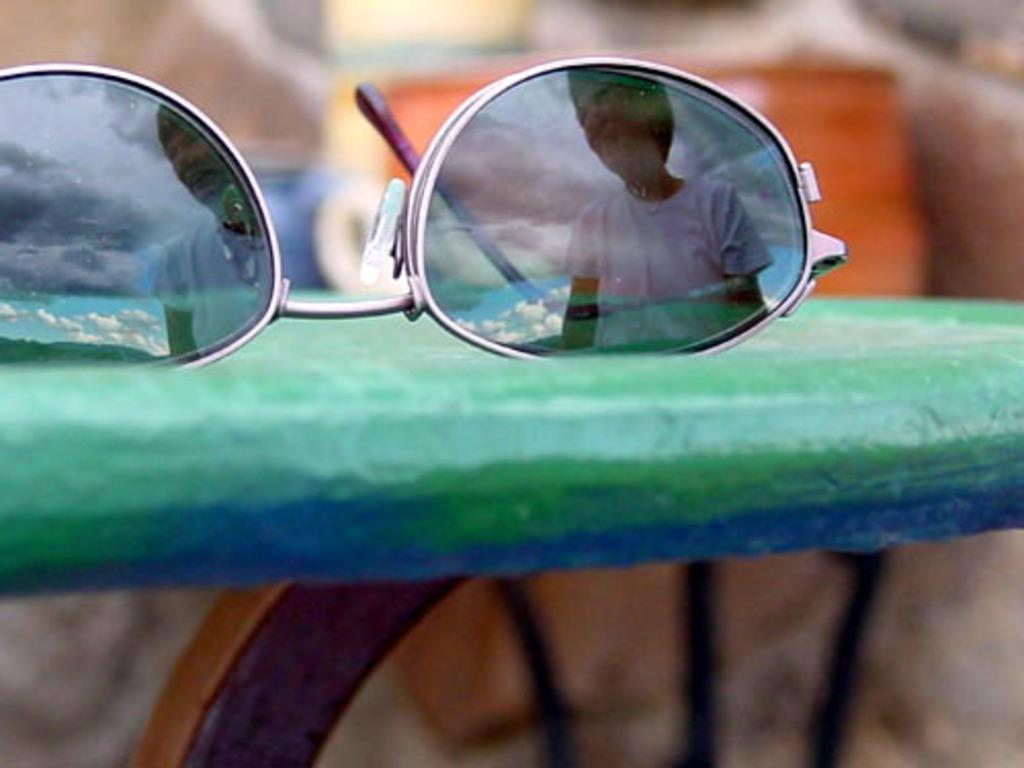What type of accessory is visible in the image? There are spectacles visible in the image. What type of furniture is visible in the image? There is no furniture visible in the image; only spectacles are present. What does the person wearing the spectacles look like in the image? The provided facts do not give any information about the person wearing the spectacles, so it is not possible to answer that question. 